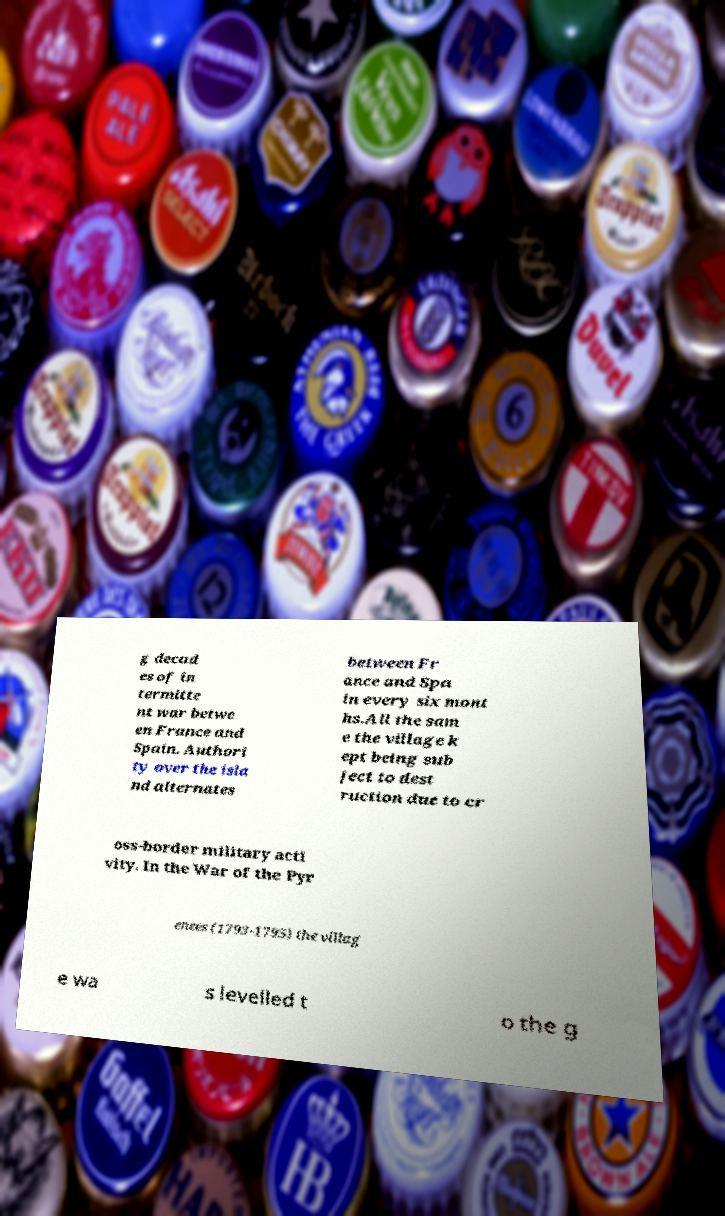Please identify and transcribe the text found in this image. g decad es of in termitte nt war betwe en France and Spain. Authori ty over the isla nd alternates between Fr ance and Spa in every six mont hs.All the sam e the village k ept being sub ject to dest ruction due to cr oss-border military acti vity. In the War of the Pyr enees (1793-1795) the villag e wa s levelled t o the g 